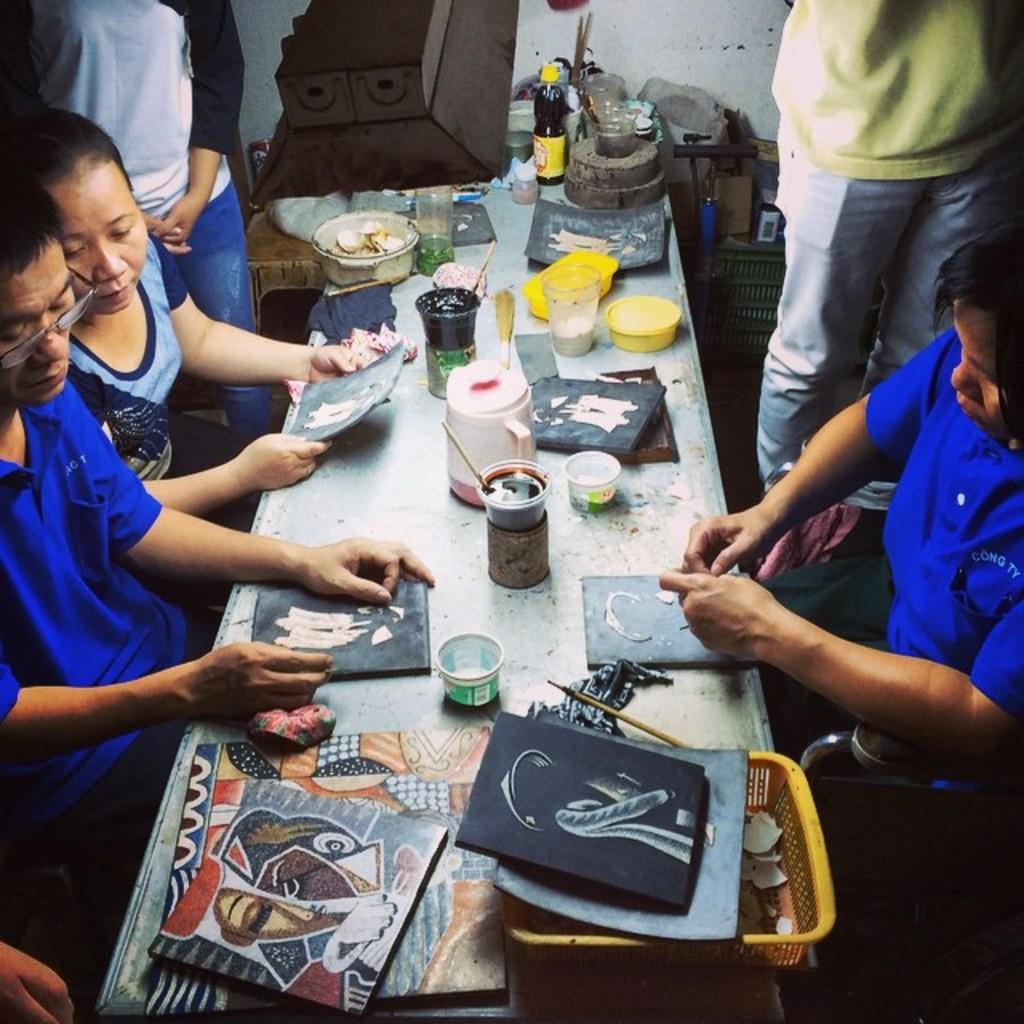Please provide a concise description of this image. This picture shows few people seated and couple of them are standing and we see they are painting and we see few cups, brush and a bottle on the table. 